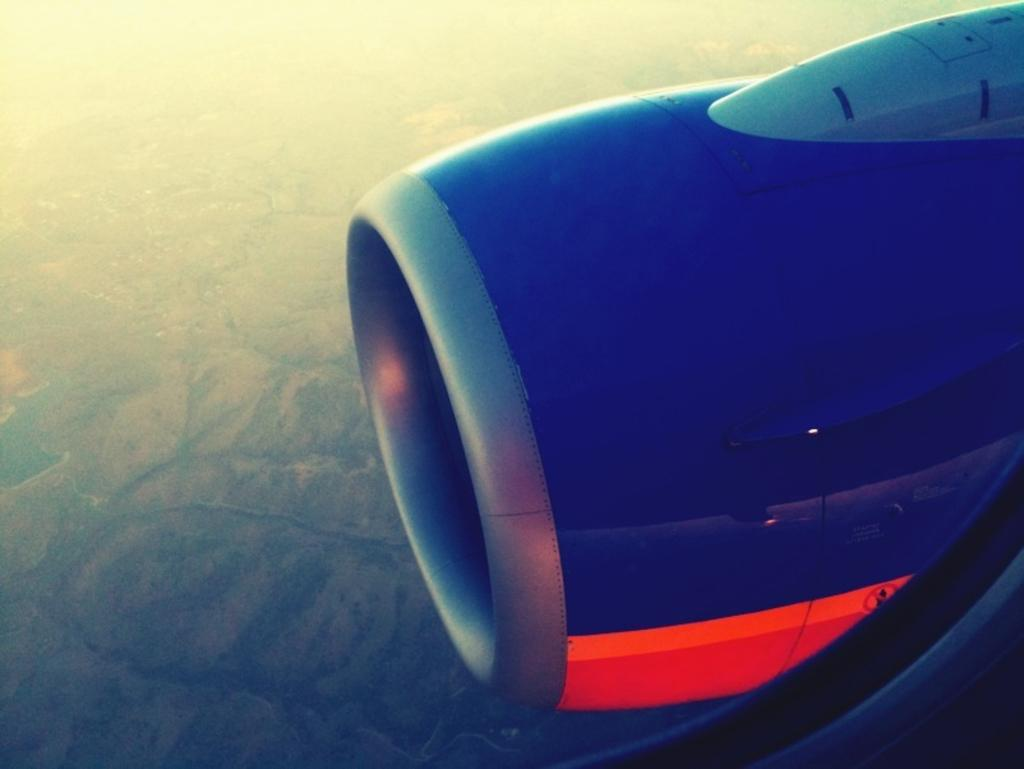What is the main subject of the image? The main subject of the image is an aircraft turbine. What color is the aircraft turbine? The aircraft turbine is blue in color. On which side of the image is the aircraft turbine located? The aircraft turbine is on the right side of the image. What type of plough can be seen in the image? There is no plough present in the image. What list is visible in the image? There is no list present in the image. Where is the playground located in the image? There is no playground present in the image. 